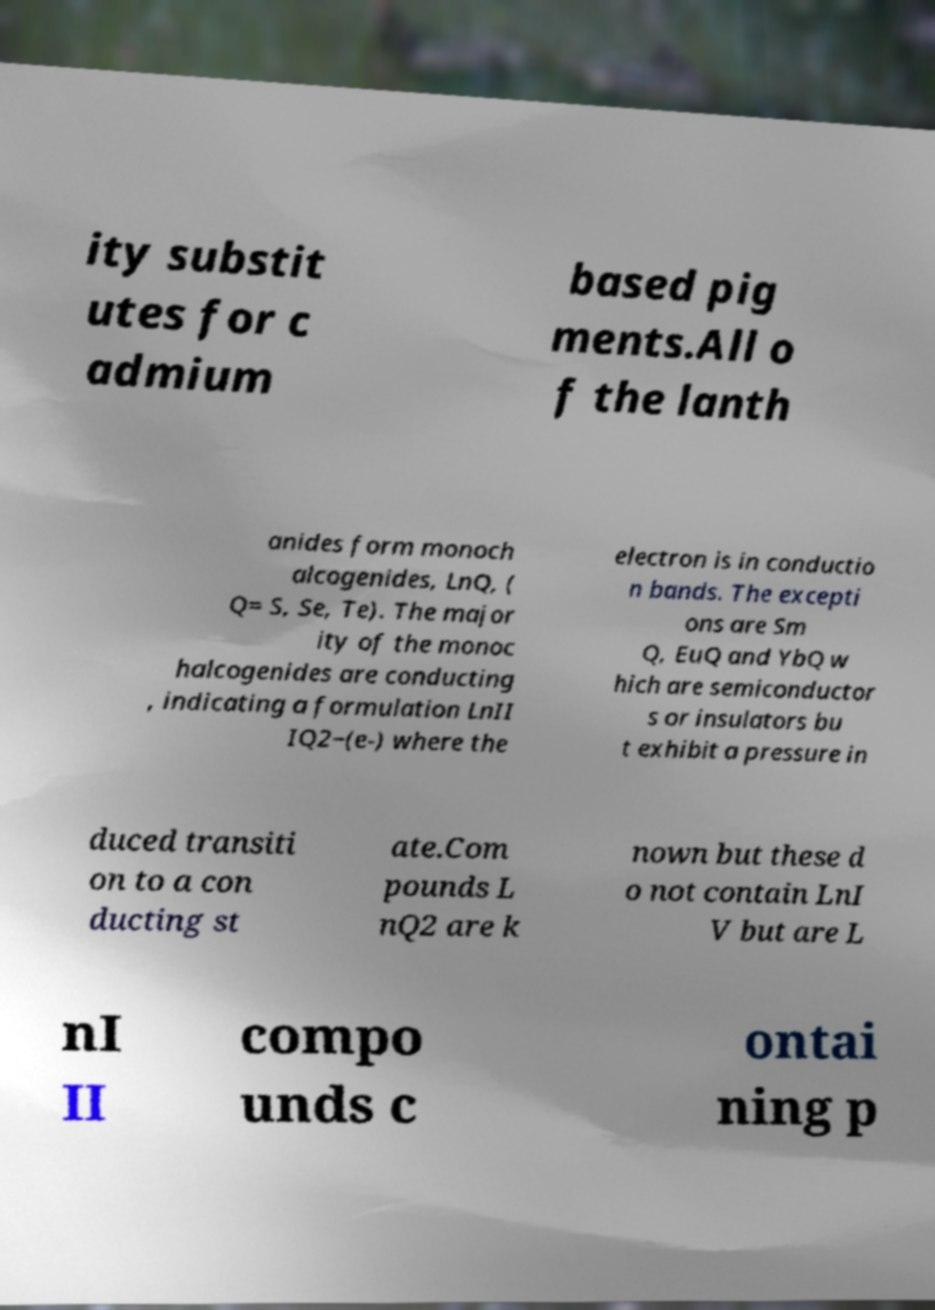I need the written content from this picture converted into text. Can you do that? ity substit utes for c admium based pig ments.All o f the lanth anides form monoch alcogenides, LnQ, ( Q= S, Se, Te). The major ity of the monoc halcogenides are conducting , indicating a formulation LnII IQ2−(e-) where the electron is in conductio n bands. The excepti ons are Sm Q, EuQ and YbQ w hich are semiconductor s or insulators bu t exhibit a pressure in duced transiti on to a con ducting st ate.Com pounds L nQ2 are k nown but these d o not contain LnI V but are L nI II compo unds c ontai ning p 